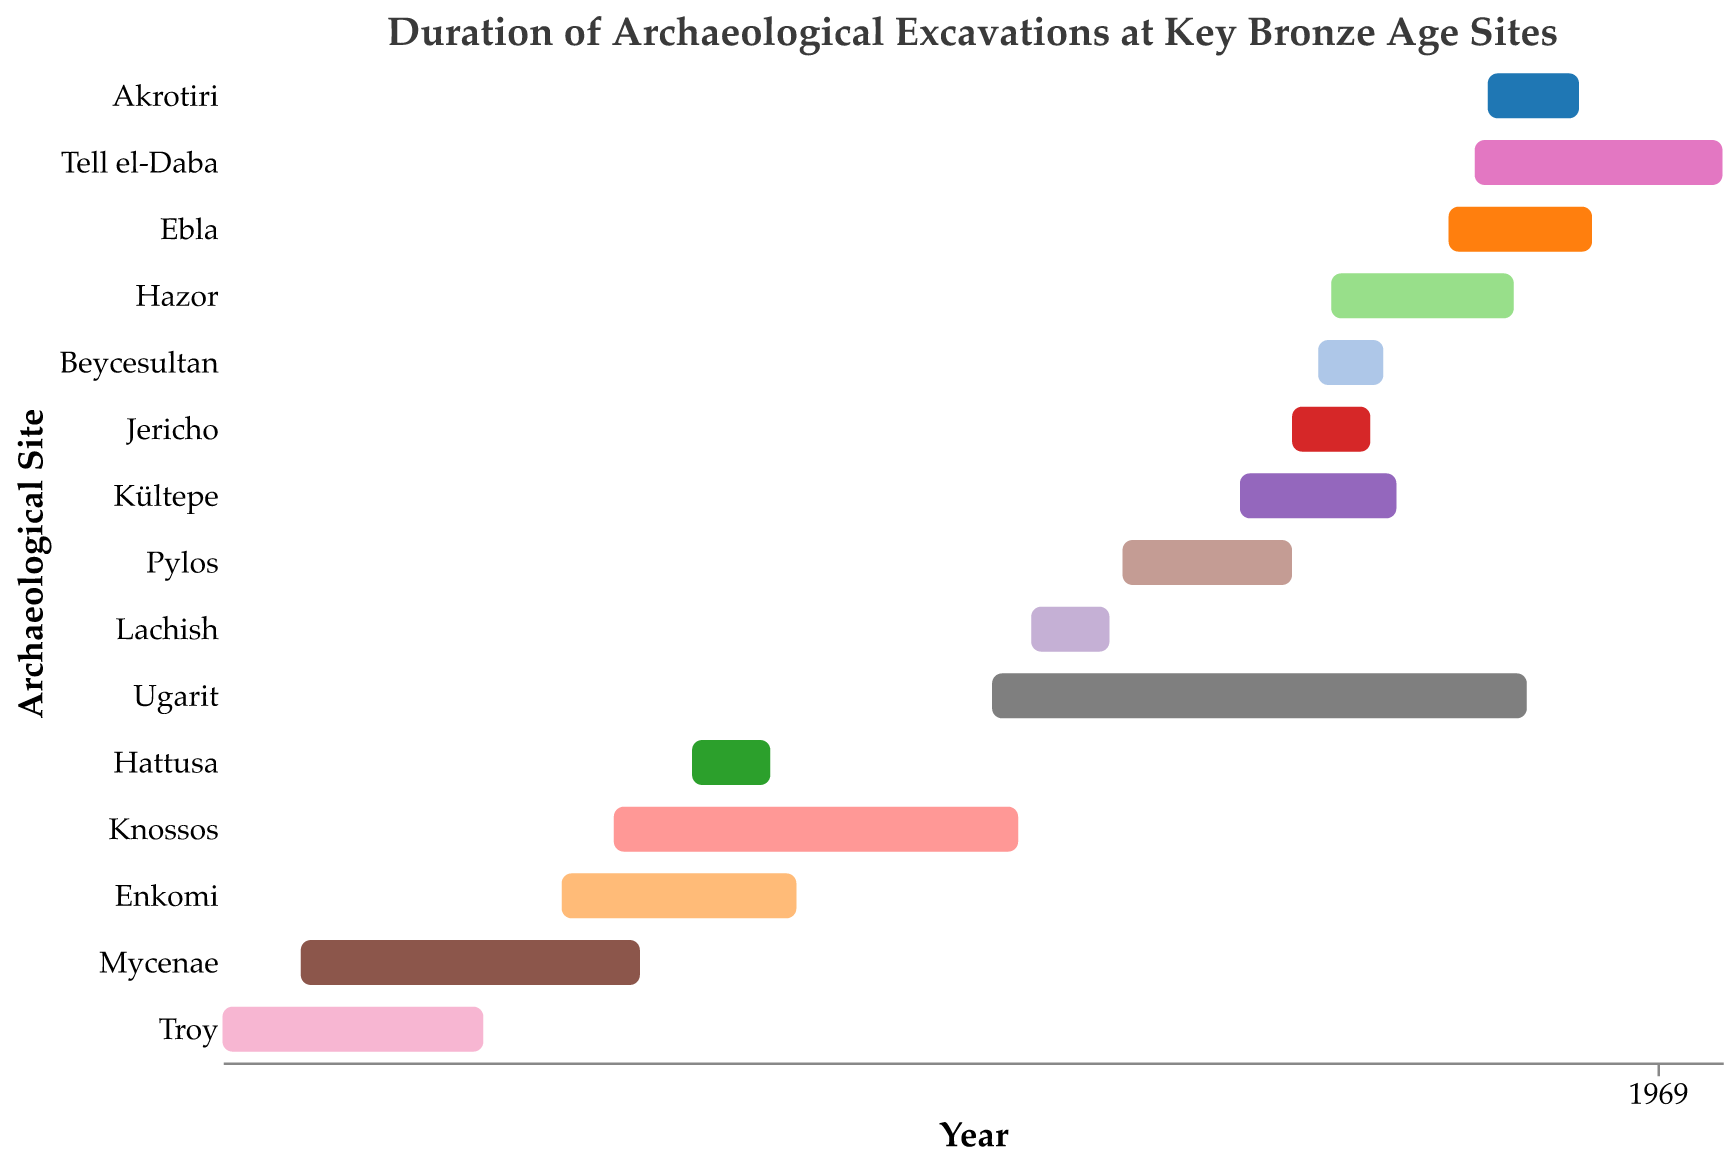What is the title of the chart? The title is written at the top of the Gantt Chart. It helps us understand what the data being presented is about. The title of this chart is "Duration of Archaeological Excavations at Key Bronze Age Sites".
Answer: Duration of Archaeological Excavations at Key Bronze Age Sites In which year did excavations start at Troy? Find the bar that represents Troy and look at the starting point on the x-axis. Excavations at Troy started in 1870.
Answer: 1870 Which site had the longest excavation period? Measure the length of each site's bar. The site with the longest bar represents the longest excavation period. Ugarit's bar extends from 1929 to 1970, a duration of 41 years, which is the longest.
Answer: Ugarit Which two sites had overlapping excavation periods starting in the 1960s? Look for bars starting in the 1960s that overlap. "Tell el-Daba" (1966-1985) and "Akrotiri" (1967-1974) both start in the 1960s and overlap.
Answer: Tell el-Daba and Akrotiri How many sites had excavation periods that lasted more than 20 years? Determine the duration of excavation for each site by subtracting the start year from the end year. Count the number of sites with durations greater than 20 years. Troy (20), Mycenae (26), Ugarit (41), and Tell el-Daba (19). The count is 4.
Answer: 4 Which site ended its excavation in 1931? Find the bar whose end point aligns with the year 1931 on the x-axis. The bar representing Knossos ends in 1931.
Answer: Knossos Did any excavations overlap between Troy and Mycenae? Look at the bars representing Troy and Mycenae and check for any overlap. Troy (1870-1890) overlaps with Mycenae (1876-1902) from 1876 to 1890.
Answer: Yes Which site had excavations that overlapped with the most number of other sites? Identify the site whose bar overlaps with the greatest number of other bars. Ugarit (1929-1970) overlaps with Kültepe, Hazor, Tell el-Daba, Ebla, and Akrotiri —a total of 5 sites.
Answer: Ugarit How many sites had excavation periods starting in the 1950s? Count the bars that start within the range 1950-1959. Jericho, Hazor, and Beycesultan each have bars starting in the 1950s.
Answer: 3 